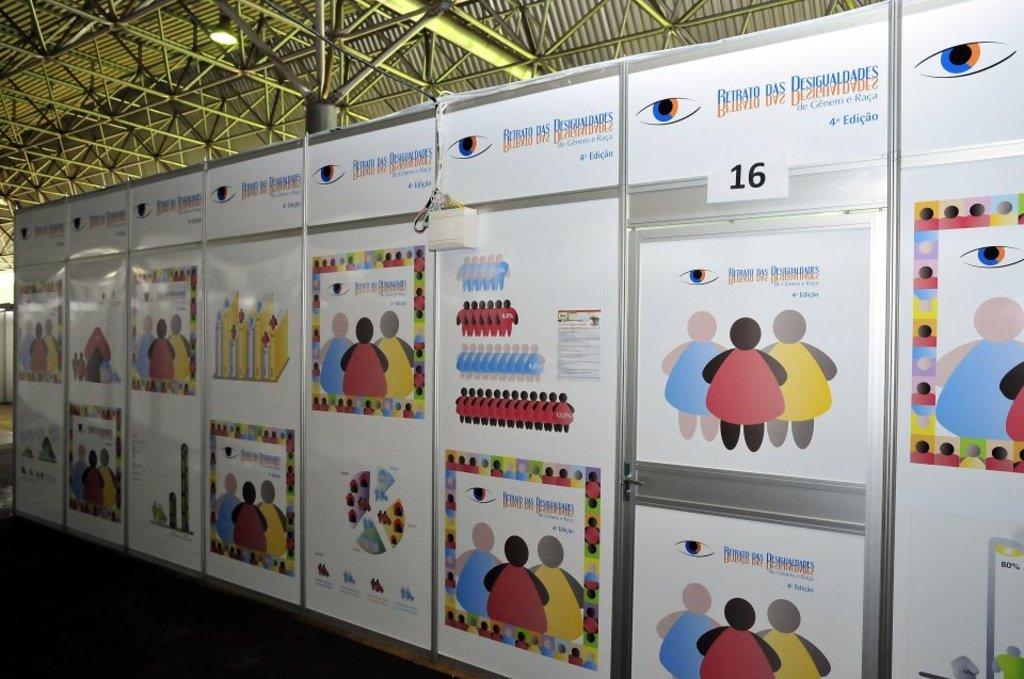What number is shown nearby?
Offer a very short reply. 16. What is the name on the top of the posters?
Keep it short and to the point. Retrato das desigualdades. 